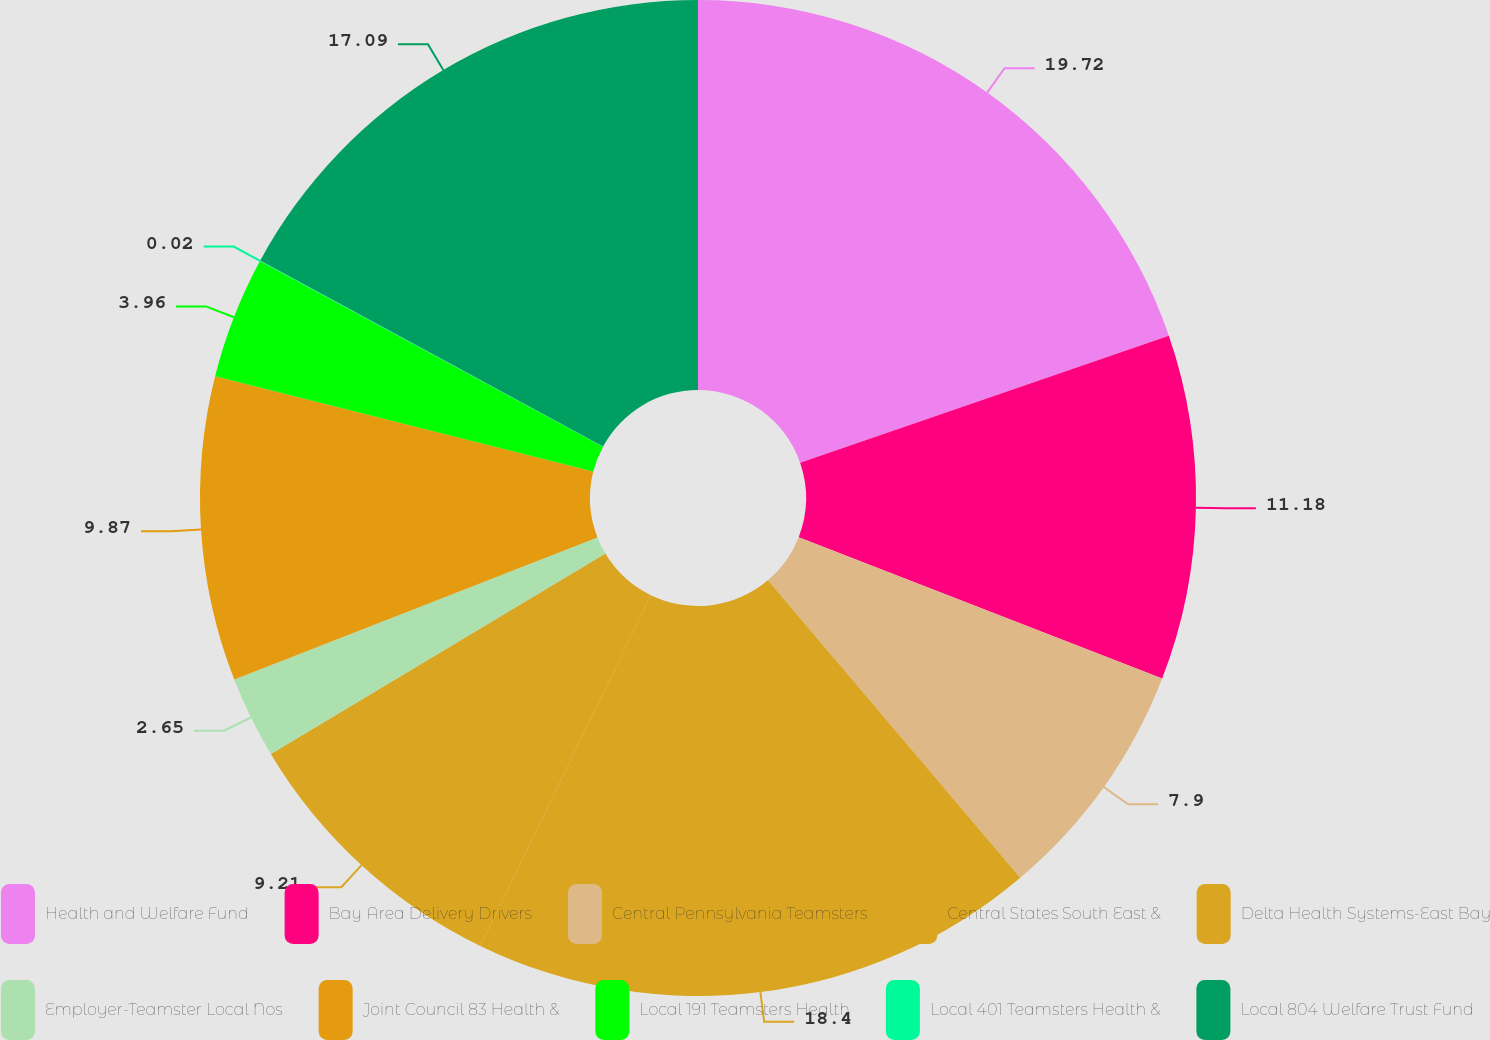Convert chart to OTSL. <chart><loc_0><loc_0><loc_500><loc_500><pie_chart><fcel>Health and Welfare Fund<fcel>Bay Area Delivery Drivers<fcel>Central Pennsylvania Teamsters<fcel>Central States South East &<fcel>Delta Health Systems-East Bay<fcel>Employer-Teamster Local Nos<fcel>Joint Council 83 Health &<fcel>Local 191 Teamsters Health<fcel>Local 401 Teamsters Health &<fcel>Local 804 Welfare Trust Fund<nl><fcel>19.72%<fcel>11.18%<fcel>7.9%<fcel>18.4%<fcel>9.21%<fcel>2.65%<fcel>9.87%<fcel>3.96%<fcel>0.02%<fcel>17.09%<nl></chart> 